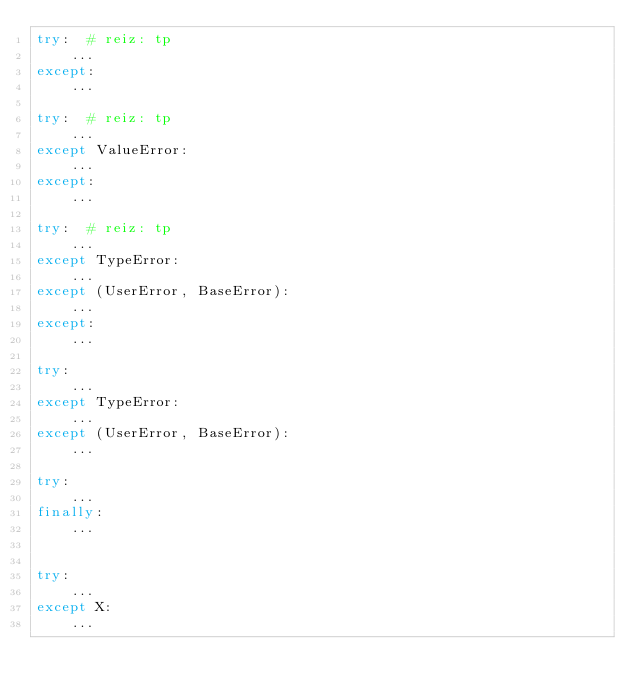<code> <loc_0><loc_0><loc_500><loc_500><_Python_>try:  # reiz: tp
    ...
except:
    ...

try:  # reiz: tp
    ...
except ValueError:
    ...
except:
    ...

try:  # reiz: tp
    ...
except TypeError:
    ...
except (UserError, BaseError):
    ...
except:
    ...

try:
    ...
except TypeError:
    ...
except (UserError, BaseError):
    ...

try:
    ...
finally:
    ...


try:
    ...
except X:
    ...
</code> 